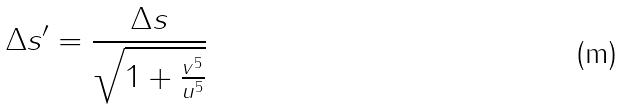<formula> <loc_0><loc_0><loc_500><loc_500>\Delta s ^ { \prime } = \frac { \Delta s } { \sqrt { 1 + \frac { v ^ { 5 } } { u ^ { 5 } } } }</formula> 